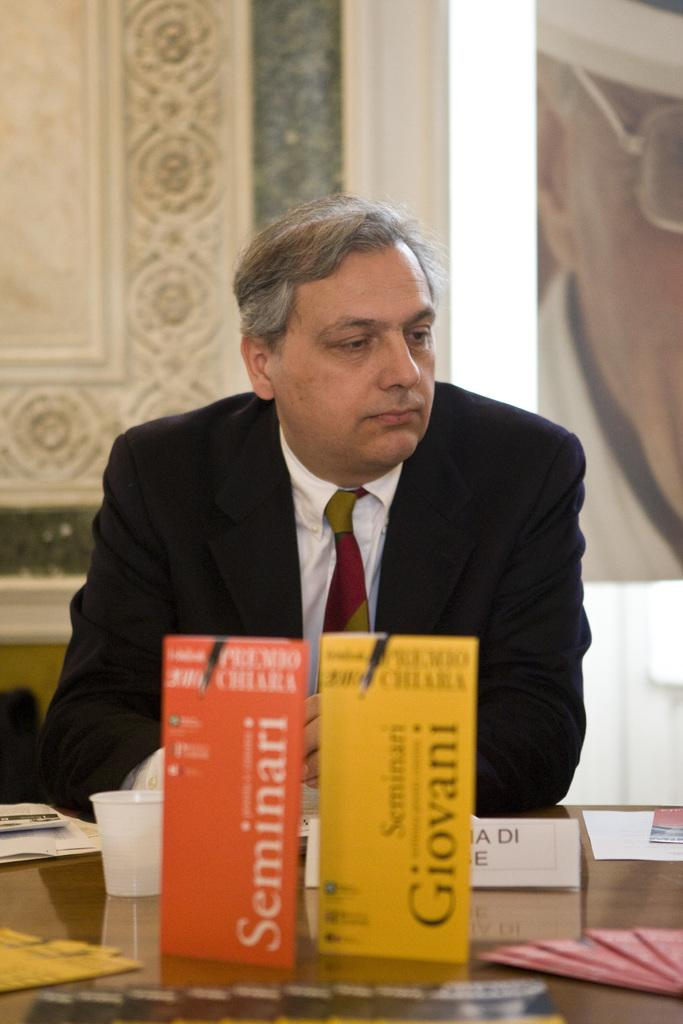Provide a one-sentence caption for the provided image. A man sits behind pamplets for Seminari and Giovani. 